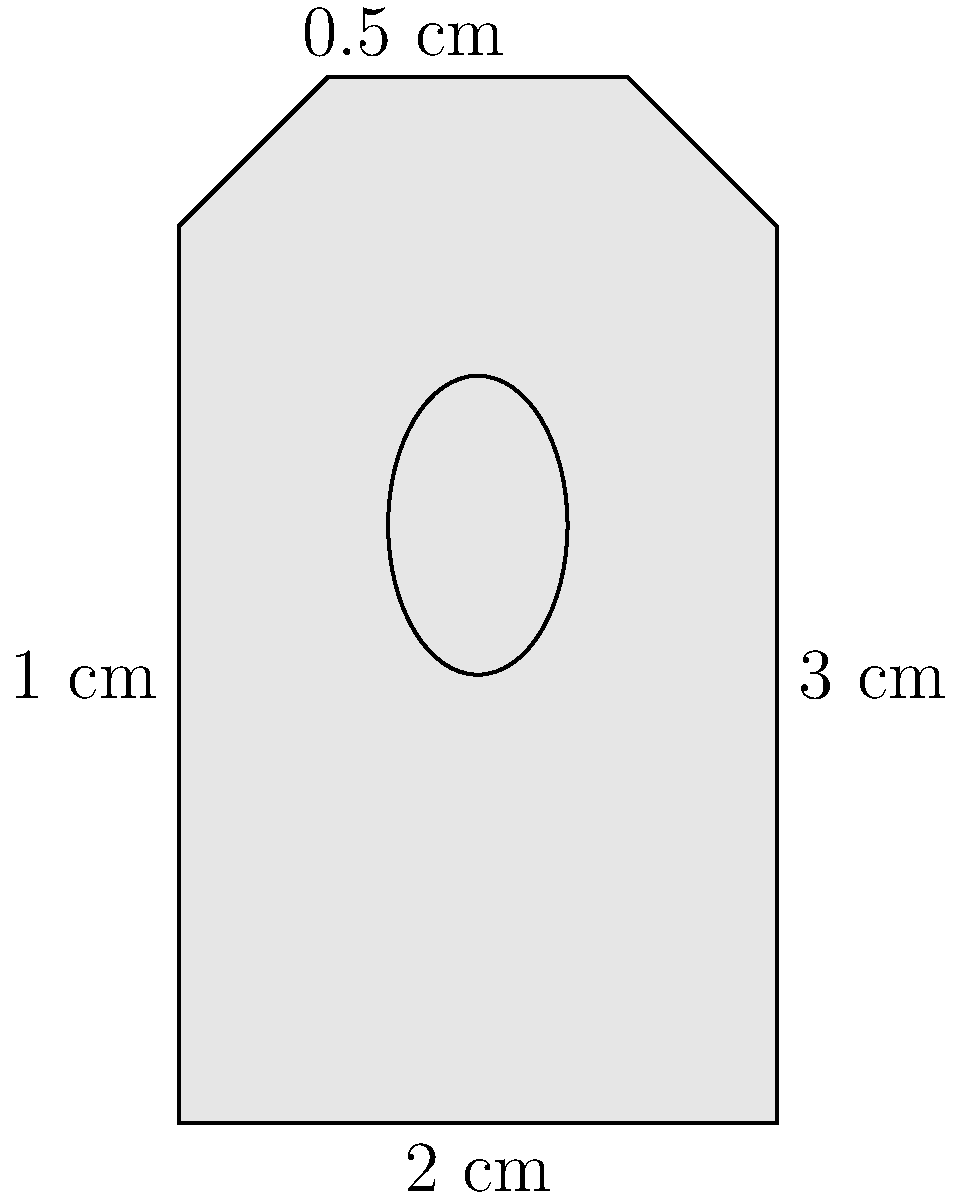As a lock and key specialist in Singapore, you need to calculate the cross-sectional area of a padlock. The padlock has a rectangular shape with rounded corners at the top. Its dimensions are 2 cm wide and 3 cm tall, with a 0.5 cm rounded top. The keyhole is elliptical with a height of 1 cm and a width of 0.6 cm. What is the total area of the padlock's cross-section in square centimeters? To find the total area of the padlock's cross-section, we'll follow these steps:

1. Calculate the area of the rectangular part:
   $A_{rectangle} = 2 \text{ cm} \times 2.5 \text{ cm} = 5 \text{ cm}^2$

2. Calculate the area of the semicircle at the top:
   $A_{semicircle} = \frac{1}{2} \times \pi \times r^2 = \frac{1}{2} \times \pi \times (0.25 \text{ cm})^2 = 0.0982 \text{ cm}^2$

3. Calculate the area of the elliptical keyhole:
   $A_{keyhole} = \pi \times a \times b = \pi \times 0.5 \text{ cm} \times 0.3 \text{ cm} = 0.4712 \text{ cm}^2$

4. Sum up the areas of the rectangle and semicircle, then subtract the keyhole area:
   $A_{total} = A_{rectangle} + A_{semicircle} - A_{keyhole}$
   $A_{total} = 5 \text{ cm}^2 + 0.0982 \text{ cm}^2 - 0.4712 \text{ cm}^2 = 4.627 \text{ cm}^2$

5. Round the result to two decimal places:
   $A_{total} \approx 4.63 \text{ cm}^2$
Answer: 4.63 cm² 